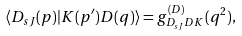Convert formula to latex. <formula><loc_0><loc_0><loc_500><loc_500>\langle D _ { s J } ( p ) | K ( p ^ { \prime } ) D ( q ) \rangle = g ^ { ( D ) } _ { D _ { s J } D K } ( q ^ { 2 } ) ,</formula> 